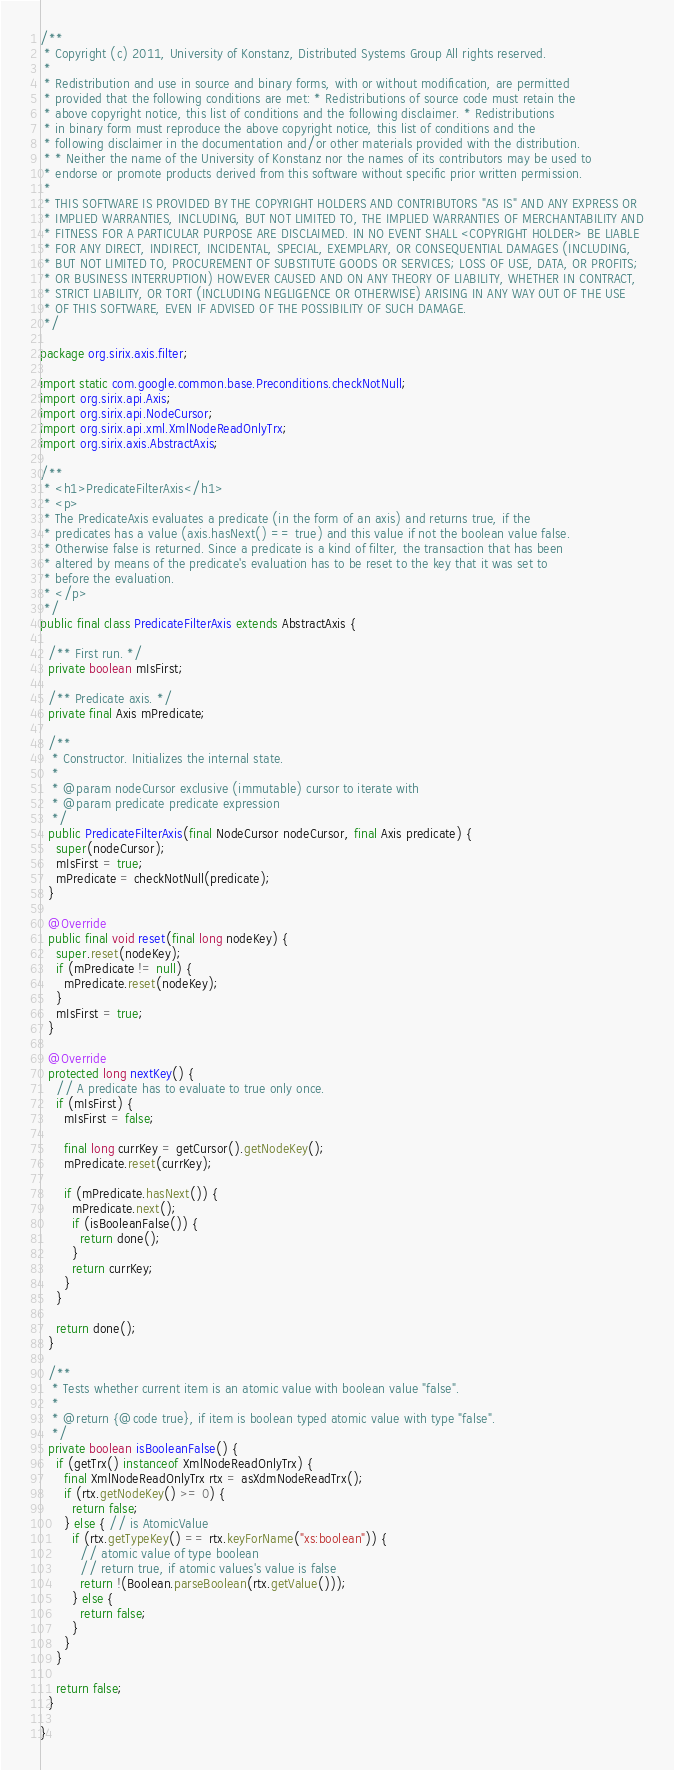<code> <loc_0><loc_0><loc_500><loc_500><_Java_>/**
 * Copyright (c) 2011, University of Konstanz, Distributed Systems Group All rights reserved.
 *
 * Redistribution and use in source and binary forms, with or without modification, are permitted
 * provided that the following conditions are met: * Redistributions of source code must retain the
 * above copyright notice, this list of conditions and the following disclaimer. * Redistributions
 * in binary form must reproduce the above copyright notice, this list of conditions and the
 * following disclaimer in the documentation and/or other materials provided with the distribution.
 * * Neither the name of the University of Konstanz nor the names of its contributors may be used to
 * endorse or promote products derived from this software without specific prior written permission.
 *
 * THIS SOFTWARE IS PROVIDED BY THE COPYRIGHT HOLDERS AND CONTRIBUTORS "AS IS" AND ANY EXPRESS OR
 * IMPLIED WARRANTIES, INCLUDING, BUT NOT LIMITED TO, THE IMPLIED WARRANTIES OF MERCHANTABILITY AND
 * FITNESS FOR A PARTICULAR PURPOSE ARE DISCLAIMED. IN NO EVENT SHALL <COPYRIGHT HOLDER> BE LIABLE
 * FOR ANY DIRECT, INDIRECT, INCIDENTAL, SPECIAL, EXEMPLARY, OR CONSEQUENTIAL DAMAGES (INCLUDING,
 * BUT NOT LIMITED TO, PROCUREMENT OF SUBSTITUTE GOODS OR SERVICES; LOSS OF USE, DATA, OR PROFITS;
 * OR BUSINESS INTERRUPTION) HOWEVER CAUSED AND ON ANY THEORY OF LIABILITY, WHETHER IN CONTRACT,
 * STRICT LIABILITY, OR TORT (INCLUDING NEGLIGENCE OR OTHERWISE) ARISING IN ANY WAY OUT OF THE USE
 * OF THIS SOFTWARE, EVEN IF ADVISED OF THE POSSIBILITY OF SUCH DAMAGE.
 */

package org.sirix.axis.filter;

import static com.google.common.base.Preconditions.checkNotNull;
import org.sirix.api.Axis;
import org.sirix.api.NodeCursor;
import org.sirix.api.xml.XmlNodeReadOnlyTrx;
import org.sirix.axis.AbstractAxis;

/**
 * <h1>PredicateFilterAxis</h1>
 * <p>
 * The PredicateAxis evaluates a predicate (in the form of an axis) and returns true, if the
 * predicates has a value (axis.hasNext() == true) and this value if not the boolean value false.
 * Otherwise false is returned. Since a predicate is a kind of filter, the transaction that has been
 * altered by means of the predicate's evaluation has to be reset to the key that it was set to
 * before the evaluation.
 * </p>
 */
public final class PredicateFilterAxis extends AbstractAxis {

  /** First run. */
  private boolean mIsFirst;

  /** Predicate axis. */
  private final Axis mPredicate;

  /**
   * Constructor. Initializes the internal state.
   *
   * @param nodeCursor exclusive (immutable) cursor to iterate with
   * @param predicate predicate expression
   */
  public PredicateFilterAxis(final NodeCursor nodeCursor, final Axis predicate) {
    super(nodeCursor);
    mIsFirst = true;
    mPredicate = checkNotNull(predicate);
  }

  @Override
  public final void reset(final long nodeKey) {
    super.reset(nodeKey);
    if (mPredicate != null) {
      mPredicate.reset(nodeKey);
    }
    mIsFirst = true;
  }

  @Override
  protected long nextKey() {
    // A predicate has to evaluate to true only once.
    if (mIsFirst) {
      mIsFirst = false;

      final long currKey = getCursor().getNodeKey();
      mPredicate.reset(currKey);

      if (mPredicate.hasNext()) {
        mPredicate.next();
        if (isBooleanFalse()) {
          return done();
        }
        return currKey;
      }
    }

    return done();
  }

  /**
   * Tests whether current item is an atomic value with boolean value "false".
   *
   * @return {@code true}, if item is boolean typed atomic value with type "false".
   */
  private boolean isBooleanFalse() {
    if (getTrx() instanceof XmlNodeReadOnlyTrx) {
      final XmlNodeReadOnlyTrx rtx = asXdmNodeReadTrx();
      if (rtx.getNodeKey() >= 0) {
        return false;
      } else { // is AtomicValue
        if (rtx.getTypeKey() == rtx.keyForName("xs:boolean")) {
          // atomic value of type boolean
          // return true, if atomic values's value is false
          return !(Boolean.parseBoolean(rtx.getValue()));
        } else {
          return false;
        }
      }
    }

    return false;
  }

}
</code> 